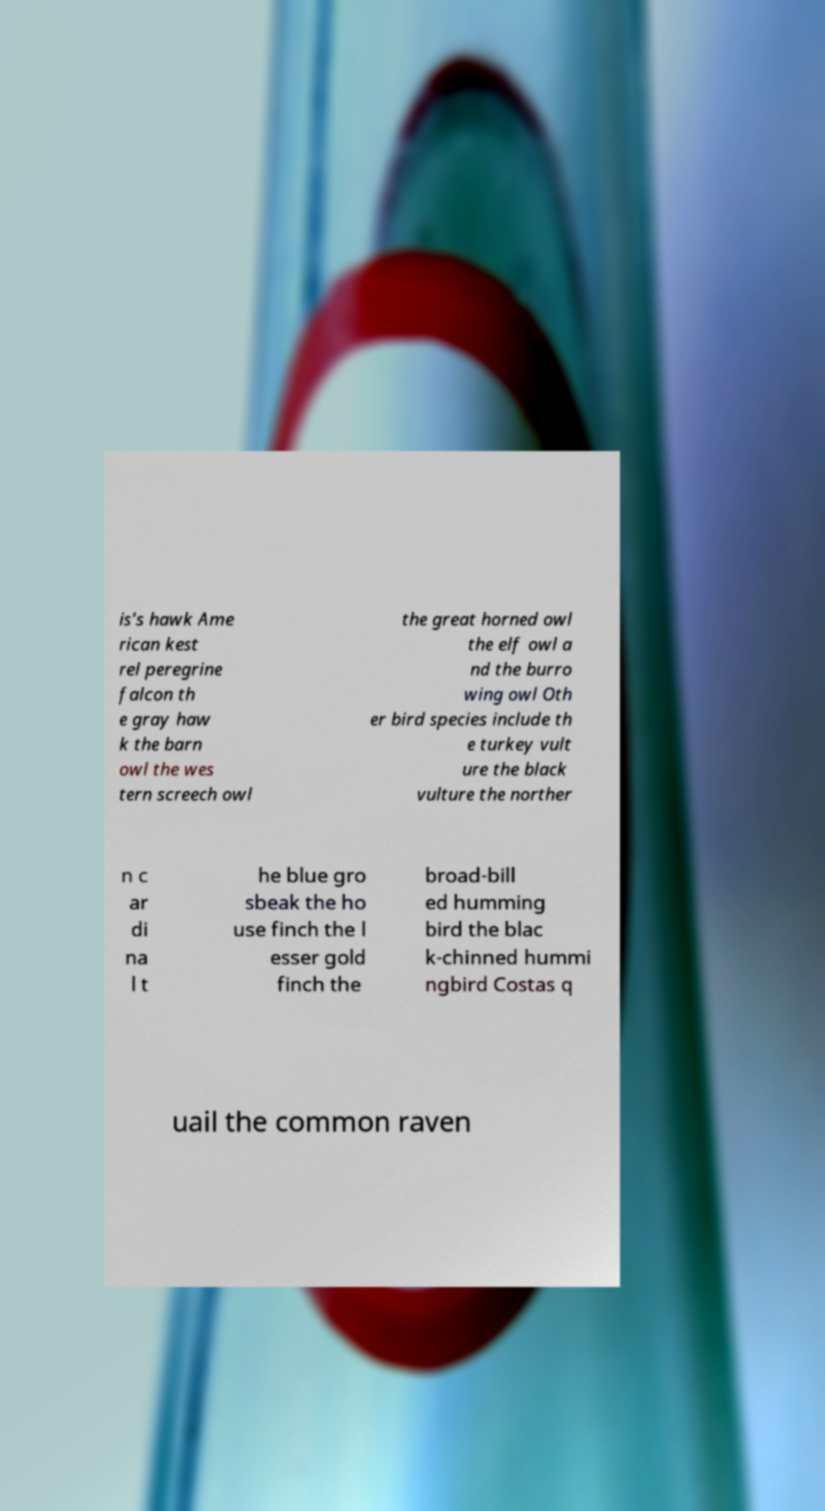Could you extract and type out the text from this image? is's hawk Ame rican kest rel peregrine falcon th e gray haw k the barn owl the wes tern screech owl the great horned owl the elf owl a nd the burro wing owl Oth er bird species include th e turkey vult ure the black vulture the norther n c ar di na l t he blue gro sbeak the ho use finch the l esser gold finch the broad-bill ed humming bird the blac k-chinned hummi ngbird Costas q uail the common raven 